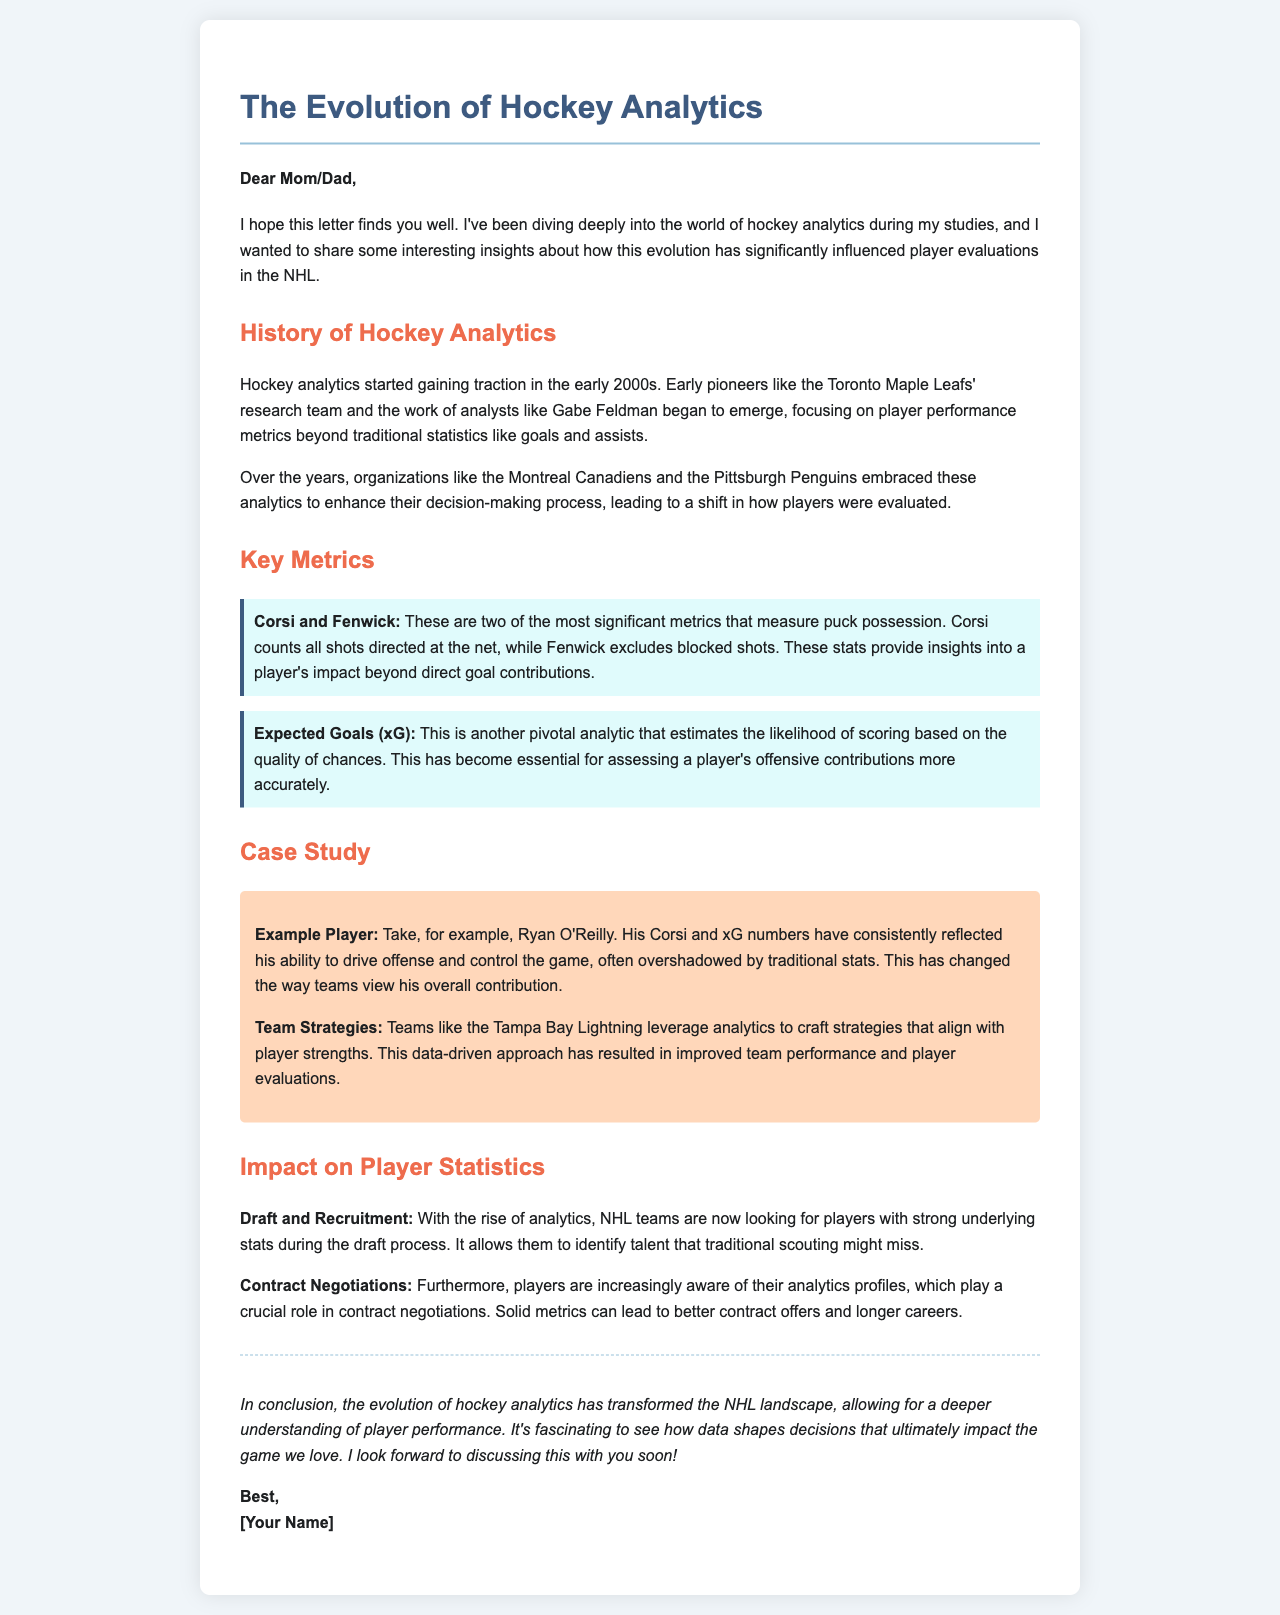What year did hockey analytics start gaining traction? The document states that hockey analytics started gaining traction in the early 2000s.
Answer: early 2000s Who are considered early pioneers of hockey analytics? The letter mentions the Toronto Maple Leafs' research team and analysts like Gabe Feldman as early pioneers.
Answer: Toronto Maple Leafs' research team and Gabe Feldman What two metrics measure puck possession? The document identifies Corsi and Fenwick as significant metrics for measuring puck possession.
Answer: Corsi and Fenwick What does the Expected Goals (xG) metric estimate? The Expected Goals (xG) metric estimates the likelihood of scoring based on the quality of chances.
Answer: likelihood of scoring Which player is highlighted as an example in the case study? The letter provides Ryan O'Reilly as an example player in the case study section.
Answer: Ryan O'Reilly What role do analytics play in contract negotiations? According to the document, solid metrics can lead to better contract offers and longer careers for players.
Answer: better contract offers and longer careers How have NHL teams changed their recruitment process due to analytics? Teams are now looking for players with strong underlying stats during the draft process.
Answer: looking for players with strong underlying stats What has been the impact of analytics on team strategies? The document states that teams like the Tampa Bay Lightning leverage analytics to craft strategies aligned with player strengths.
Answer: craft strategies aligned with player strengths What does the letter conclude about the evolution of hockey analytics? The document concludes that the evolution of hockey analytics has transformed the NHL landscape, allowing for a deeper understanding of player performance.
Answer: transformed the NHL landscape 